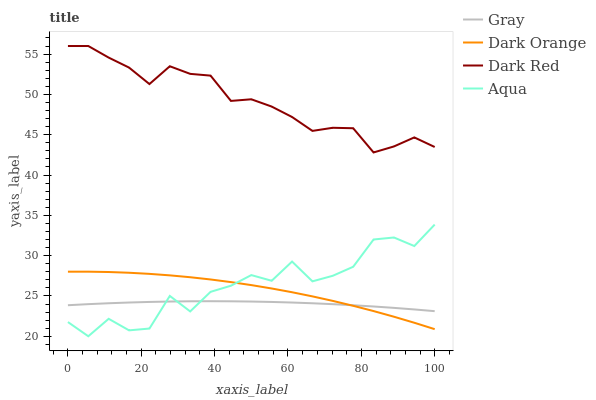Does Gray have the minimum area under the curve?
Answer yes or no. Yes. Does Dark Red have the maximum area under the curve?
Answer yes or no. Yes. Does Aqua have the minimum area under the curve?
Answer yes or no. No. Does Aqua have the maximum area under the curve?
Answer yes or no. No. Is Gray the smoothest?
Answer yes or no. Yes. Is Aqua the roughest?
Answer yes or no. Yes. Is Dark Red the smoothest?
Answer yes or no. No. Is Dark Red the roughest?
Answer yes or no. No. Does Aqua have the lowest value?
Answer yes or no. Yes. Does Dark Red have the lowest value?
Answer yes or no. No. Does Dark Red have the highest value?
Answer yes or no. Yes. Does Aqua have the highest value?
Answer yes or no. No. Is Dark Orange less than Dark Red?
Answer yes or no. Yes. Is Dark Red greater than Dark Orange?
Answer yes or no. Yes. Does Dark Orange intersect Gray?
Answer yes or no. Yes. Is Dark Orange less than Gray?
Answer yes or no. No. Is Dark Orange greater than Gray?
Answer yes or no. No. Does Dark Orange intersect Dark Red?
Answer yes or no. No. 